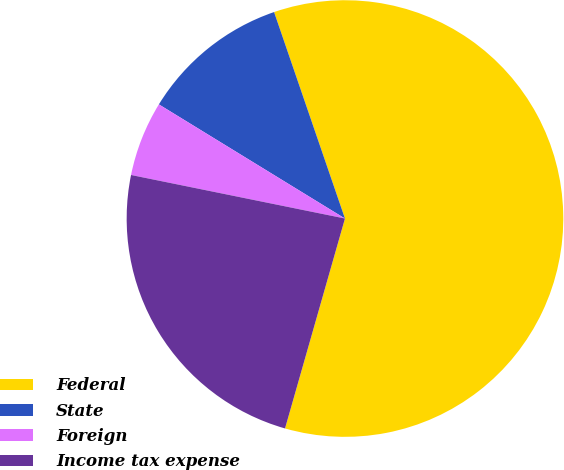<chart> <loc_0><loc_0><loc_500><loc_500><pie_chart><fcel>Federal<fcel>State<fcel>Foreign<fcel>Income tax expense<nl><fcel>59.69%<fcel>10.98%<fcel>5.56%<fcel>23.77%<nl></chart> 